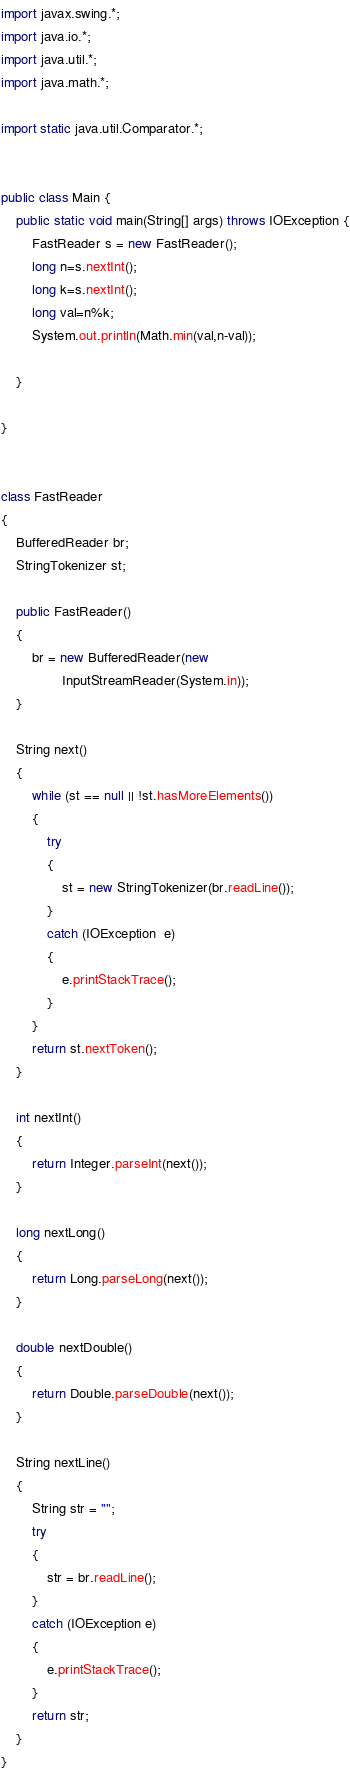Convert code to text. <code><loc_0><loc_0><loc_500><loc_500><_Java_>import javax.swing.*;
import java.io.*;
import java.util.*;
import java.math.*;

import static java.util.Comparator.*;


public class Main {
    public static void main(String[] args) throws IOException {
        FastReader s = new FastReader();
        long n=s.nextInt();
        long k=s.nextInt();
        long val=n%k;
        System.out.println(Math.min(val,n-val));

    }

}


class FastReader
{
    BufferedReader br;
    StringTokenizer st;

    public FastReader()
    {
        br = new BufferedReader(new
                InputStreamReader(System.in));
    }

    String next()
    {
        while (st == null || !st.hasMoreElements())
        {
            try
            {
                st = new StringTokenizer(br.readLine());
            }
            catch (IOException  e)
            {
                e.printStackTrace();
            }
        }
        return st.nextToken();
    }

    int nextInt()
    {
        return Integer.parseInt(next());
    }

    long nextLong()
    {
        return Long.parseLong(next());
    }

    double nextDouble()
    {
        return Double.parseDouble(next());
    }

    String nextLine()
    {
        String str = "";
        try
        {
            str = br.readLine();
        }
        catch (IOException e)
        {
            e.printStackTrace();
        }
        return str;
    }
}</code> 